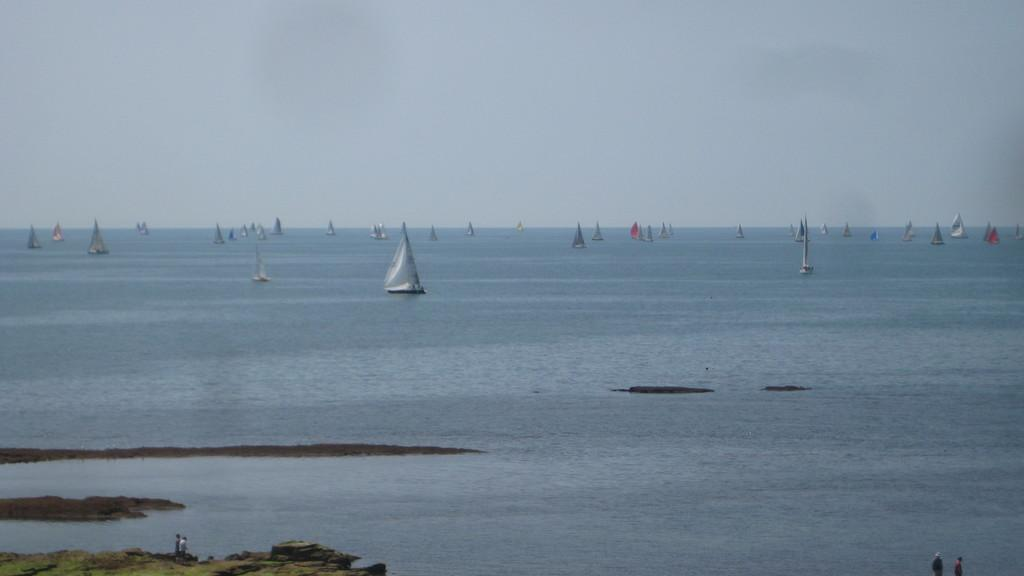What can be seen in the water in the image? There are many boats in the water. What else is present in the image besides the boats? There are people standing in the image. What are the people wearing? The people are wearing clothes. What type of natural environment is visible in the image? There is grass visible in the image. What is visible above the grass and people? The sky is visible in the image. How many legs can be seen on the control panel of the boat in the image? There is no control panel or legs mentioned in the image; it features boats in the water and people standing on the grass. 